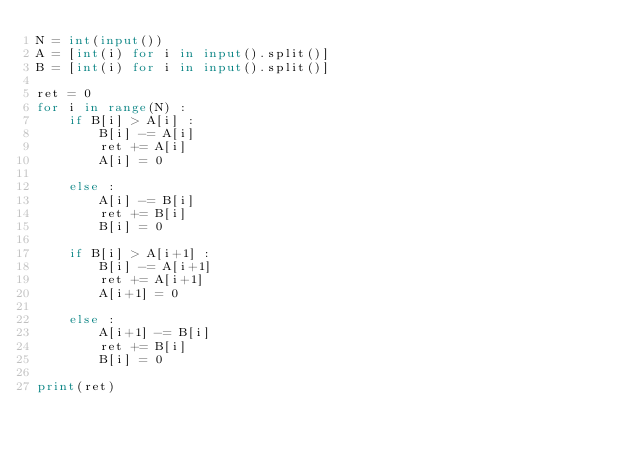<code> <loc_0><loc_0><loc_500><loc_500><_Python_>N = int(input())
A = [int(i) for i in input().split()]
B = [int(i) for i in input().split()]

ret = 0
for i in range(N) :
    if B[i] > A[i] :
        B[i] -= A[i]
        ret += A[i]
        A[i] = 0
        
    else :
        A[i] -= B[i]
        ret += B[i]
        B[i] = 0
        
    if B[i] > A[i+1] :
        B[i] -= A[i+1]
        ret += A[i+1]
        A[i+1] = 0
        
    else :
        A[i+1] -= B[i]
        ret += B[i]
        B[i] = 0
        
print(ret)</code> 